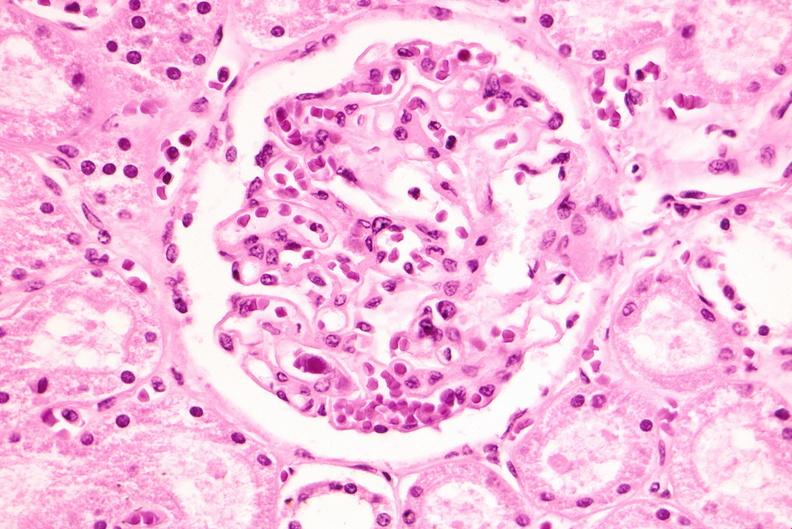does this image show kidney, cytomegalovirus?
Answer the question using a single word or phrase. Yes 